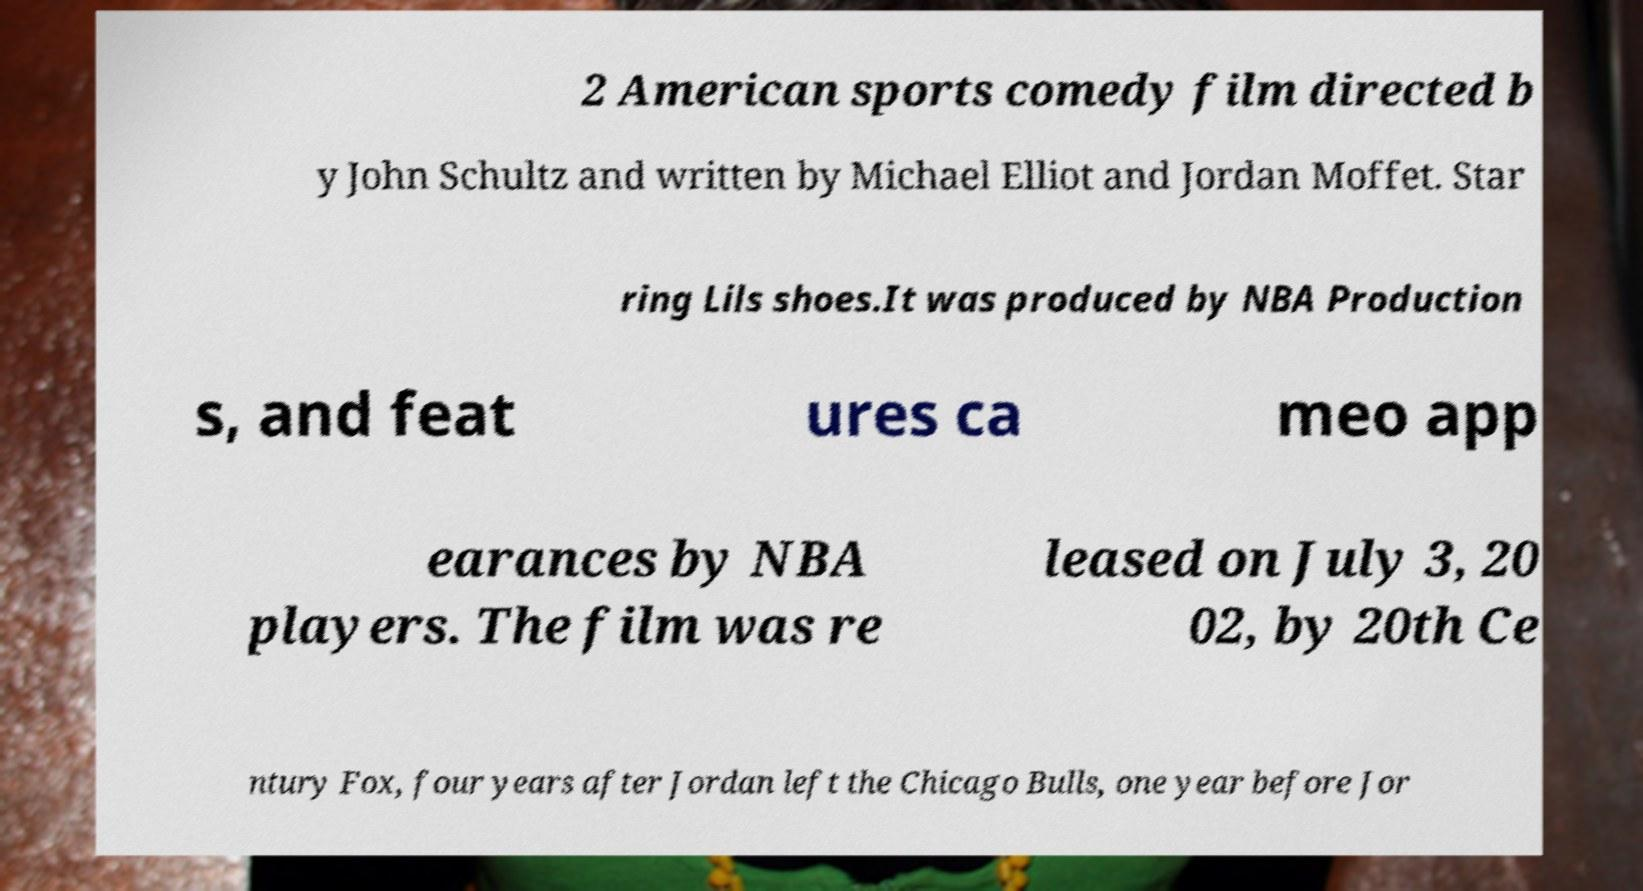Can you accurately transcribe the text from the provided image for me? 2 American sports comedy film directed b y John Schultz and written by Michael Elliot and Jordan Moffet. Star ring Lils shoes.It was produced by NBA Production s, and feat ures ca meo app earances by NBA players. The film was re leased on July 3, 20 02, by 20th Ce ntury Fox, four years after Jordan left the Chicago Bulls, one year before Jor 